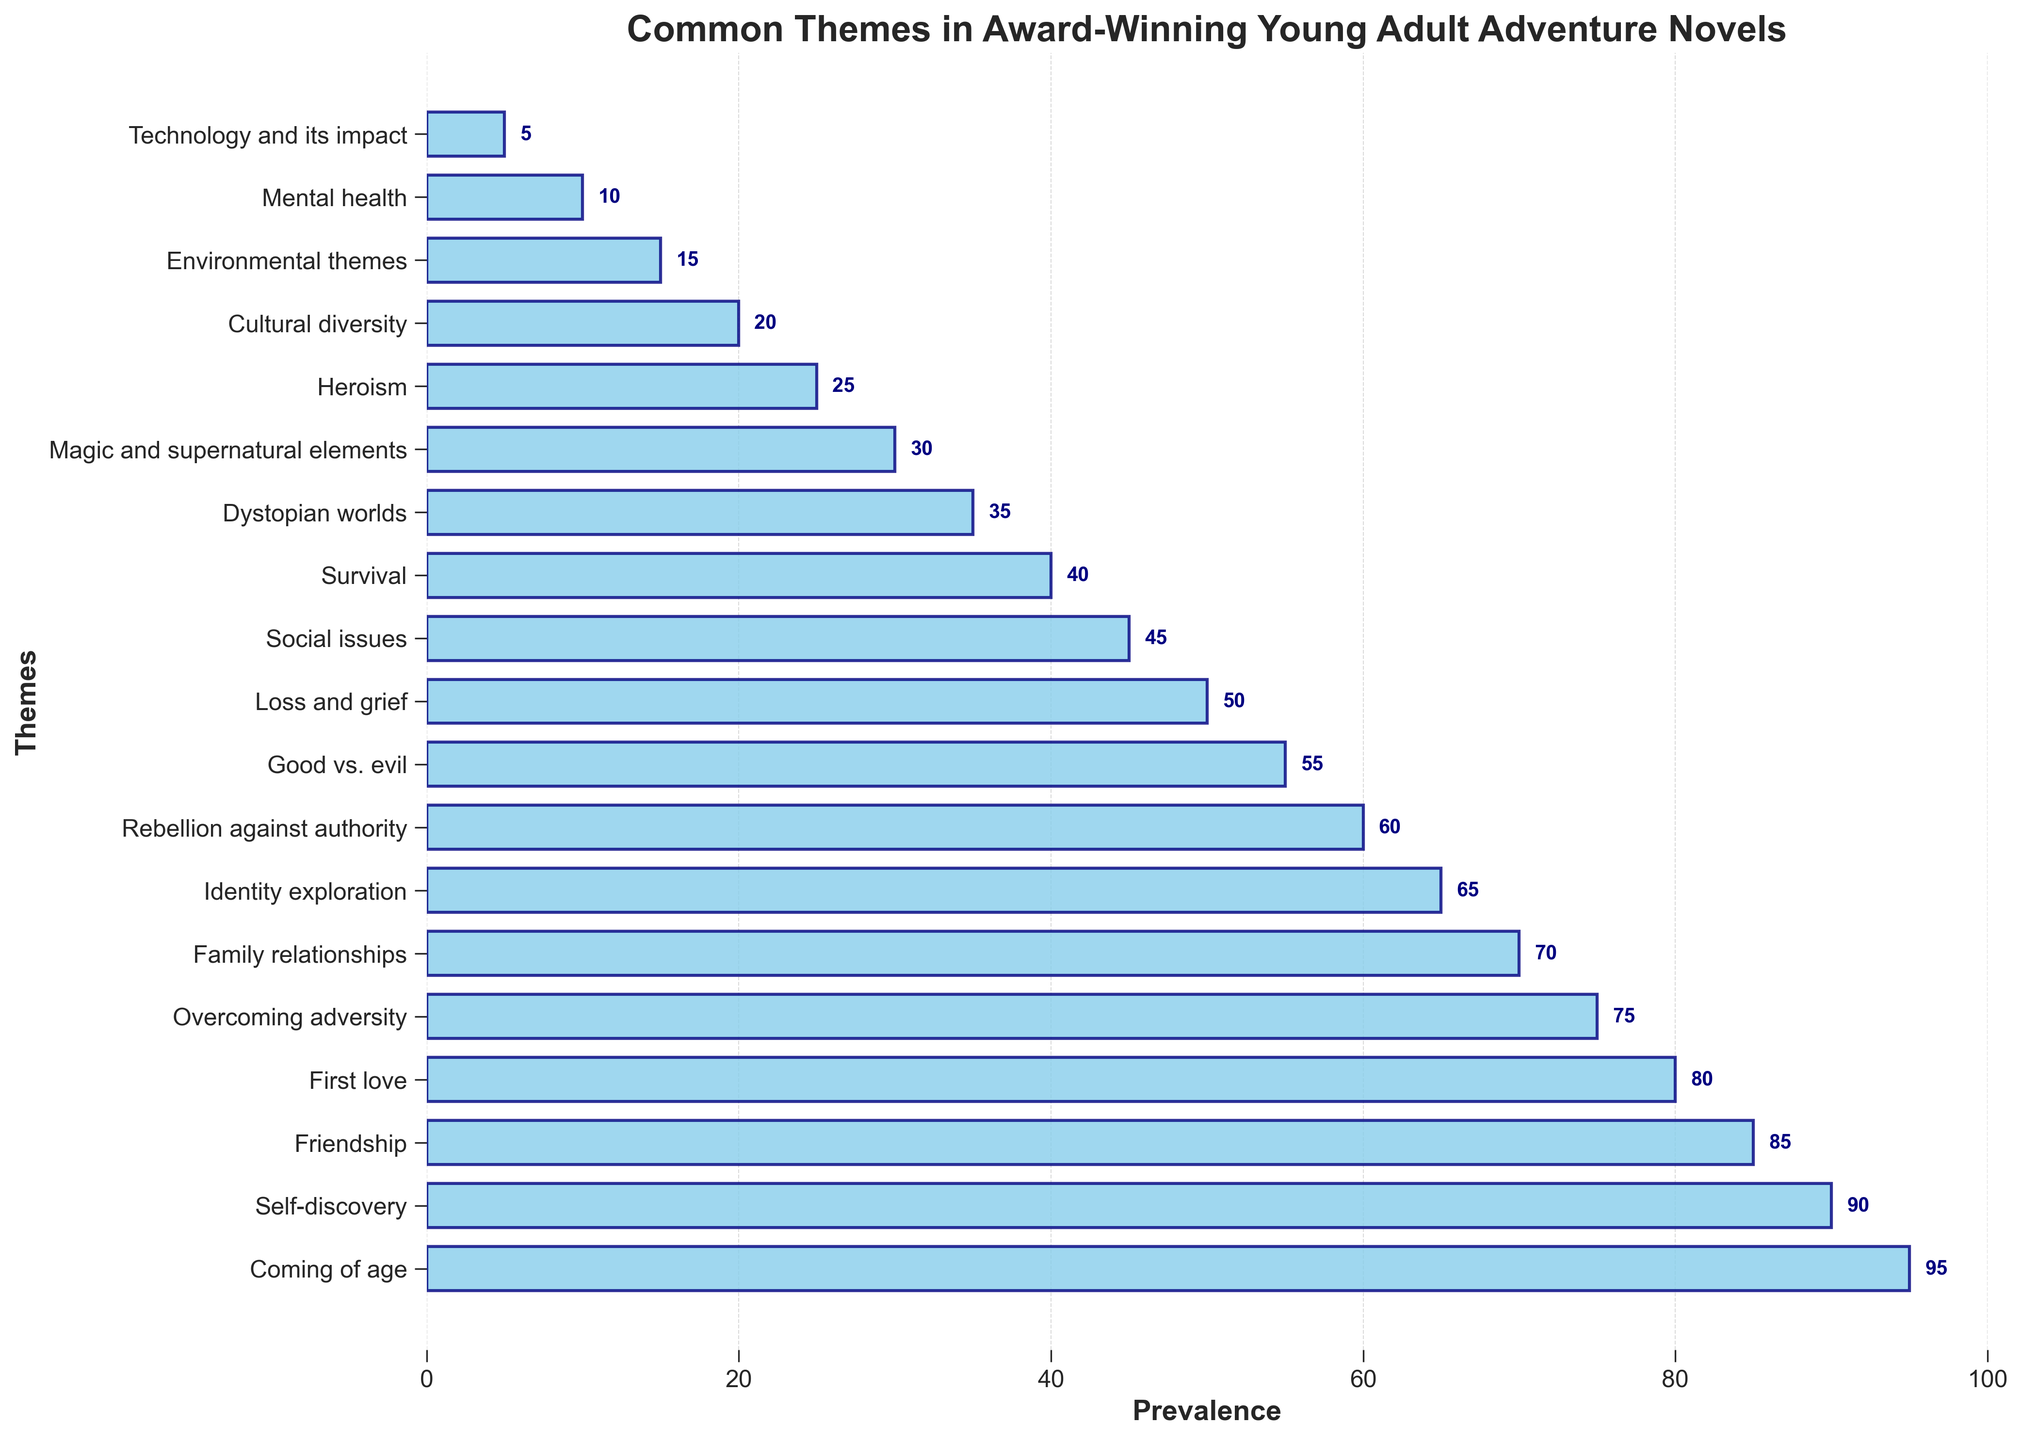What is the most prevalent theme in award-winning young adult adventure novels? The theme with the highest prevalence value in the plot is “Coming of age” which has a prevalence of 95.
Answer: Coming of age Which theme has a prevalence of 55? By inspecting the bars on the plot, the theme associated with the prevalence of 55 is “Good vs. evil.”
Answer: Good vs. evil Which theme has a higher prevalence: "Friendship" or "First love"? By comparing the bars representing "Friendship" and "First love," "Friendship" has a prevalence of 85 whereas "First love" has a prevalence of 80. Therefore, "Friendship" has a higher prevalence.
Answer: Friendship How many themes have a prevalence greater than 50? Counting the number of bars with prevalence values greater than 50, the themes are: "Coming of age" (95), "Self-discovery" (90), "Friendship" (85), "First love" (80), "Overcoming adversity" (75), "Family relationships" (70), "Identity exploration" (65), "Rebellion against authority" (60), and "Good vs. evil" (55). There are 9 themes in total.
Answer: 9 What is the difference in prevalence between the themes “Rebellion against authority” and “Mental health”? The prevalence of “Rebellion against authority” is 60, and the prevalence of “Mental health” is 10. The difference is 60 - 10 = 50.
Answer: 50 What is the sum of the prevalence values of “Loss and grief” and “Dystopian worlds”? The prevalence of “Loss and grief” is 50 and the prevalence of “Dystopian worlds” is 35. The sum is 50 + 35 = 85.
Answer: 85 What fraction of the total prevalence does the theme “Environmental themes” represent? The prevalence of “Environmental themes” is 15. The total sum of all prevalence values is 950. Therefore, the fraction is 15/950 = 0.0158.
Answer: 0.0158 Which theme related to technology has the lowest prevalence? Inspecting the plot, the theme "Technology and its impact" related to technology has the lowest prevalence of 5.
Answer: Technology and its impact What is the average prevalence of the themes rated with the top three highest values? The top three highest prevalence values are “Coming of age” (95), “Self-discovery” (90), and “Friendship” (85). The average is calculated as (95 + 90 + 85) / 3 = 270 / 3 = 90.
Answer: 90 